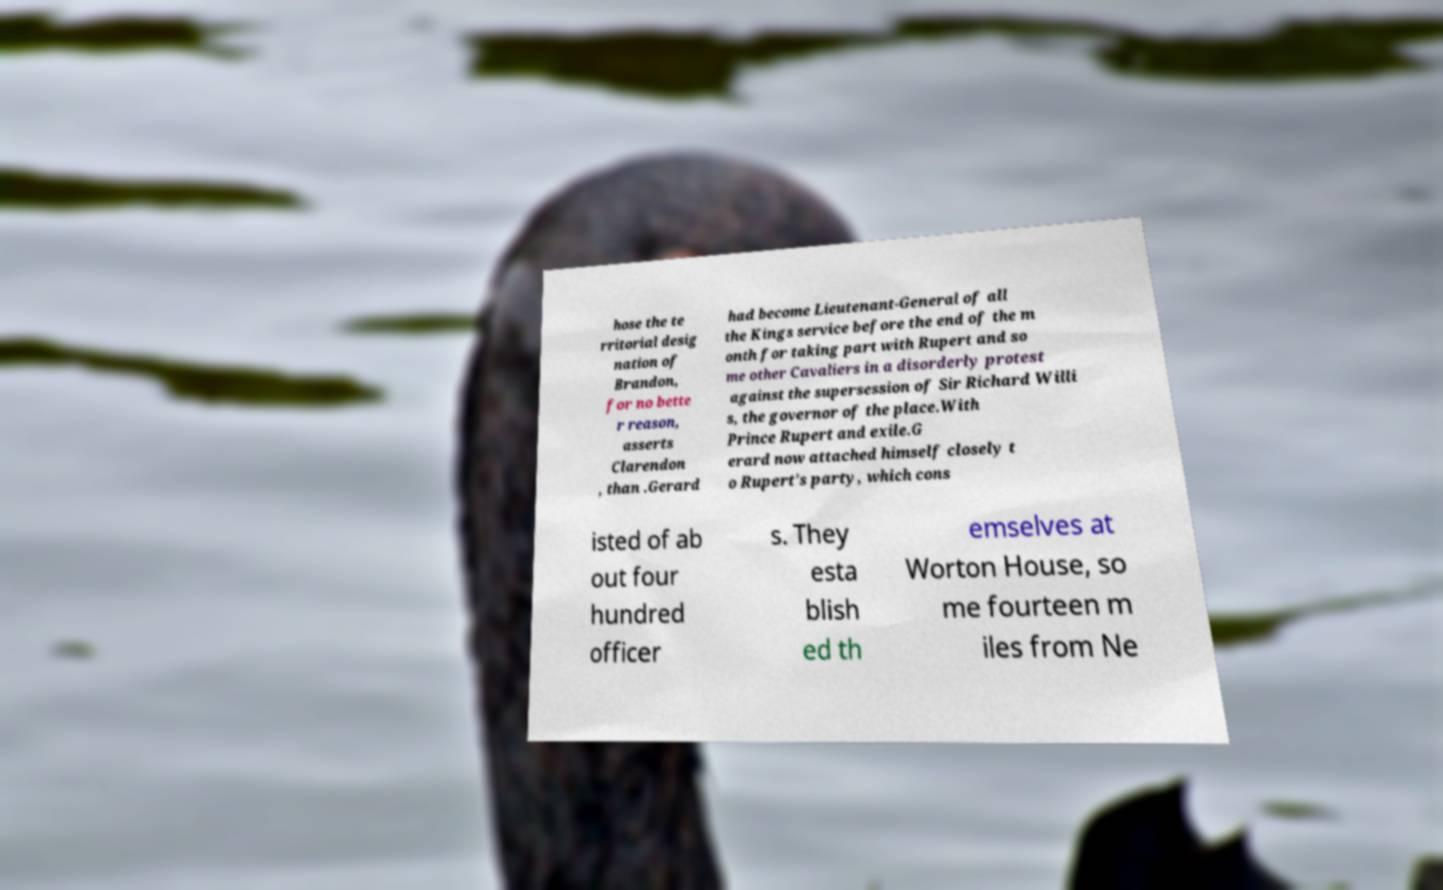There's text embedded in this image that I need extracted. Can you transcribe it verbatim? hose the te rritorial desig nation of Brandon, for no bette r reason, asserts Clarendon , than .Gerard had become Lieutenant-General of all the Kings service before the end of the m onth for taking part with Rupert and so me other Cavaliers in a disorderly protest against the supersession of Sir Richard Willi s, the governor of the place.With Prince Rupert and exile.G erard now attached himself closely t o Rupert's party, which cons isted of ab out four hundred officer s. They esta blish ed th emselves at Worton House, so me fourteen m iles from Ne 